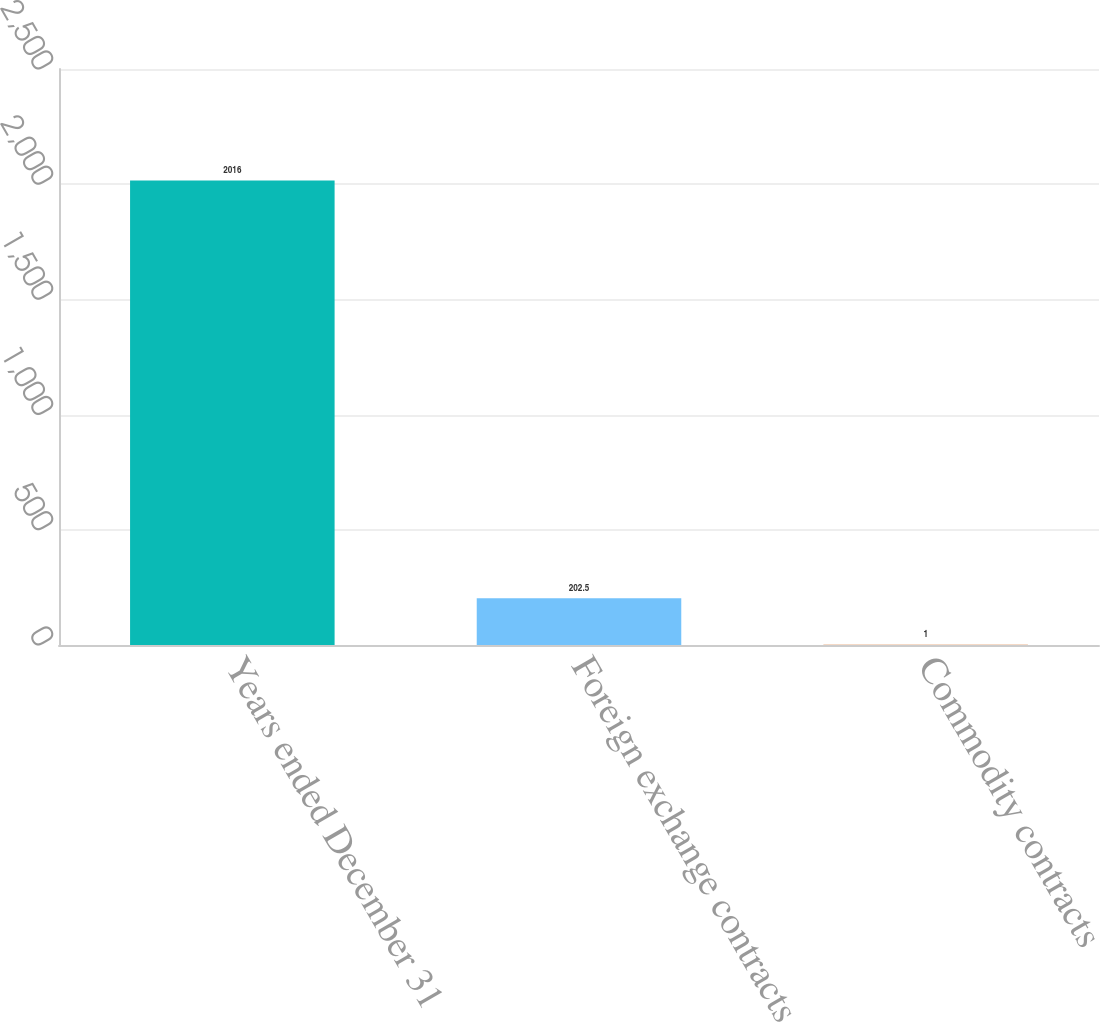Convert chart. <chart><loc_0><loc_0><loc_500><loc_500><bar_chart><fcel>Years ended December 31<fcel>Foreign exchange contracts<fcel>Commodity contracts<nl><fcel>2016<fcel>202.5<fcel>1<nl></chart> 